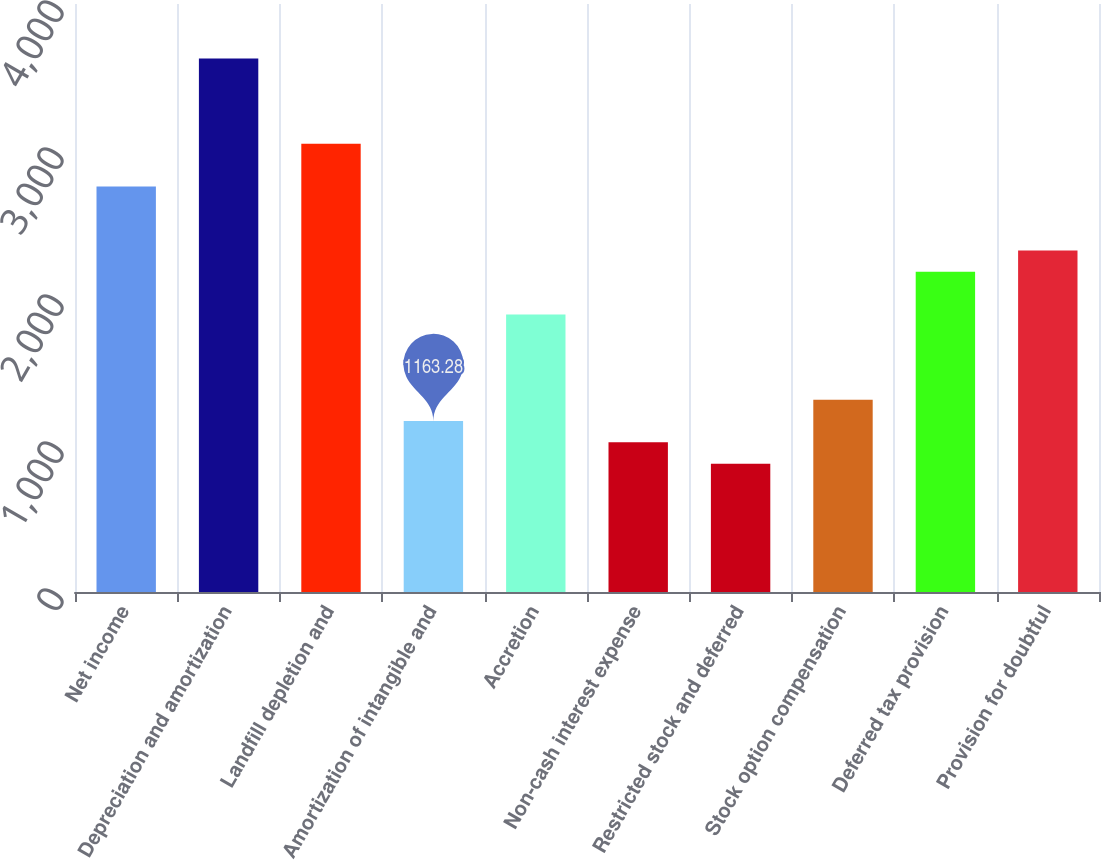Convert chart to OTSL. <chart><loc_0><loc_0><loc_500><loc_500><bar_chart><fcel>Net income<fcel>Depreciation and amortization<fcel>Landfill depletion and<fcel>Amortization of intangible and<fcel>Accretion<fcel>Non-cash interest expense<fcel>Restricted stock and deferred<fcel>Stock option compensation<fcel>Deferred tax provision<fcel>Provision for doubtful<nl><fcel>2758.94<fcel>3629.3<fcel>3049.06<fcel>1163.28<fcel>1888.58<fcel>1018.22<fcel>873.16<fcel>1308.34<fcel>2178.7<fcel>2323.76<nl></chart> 